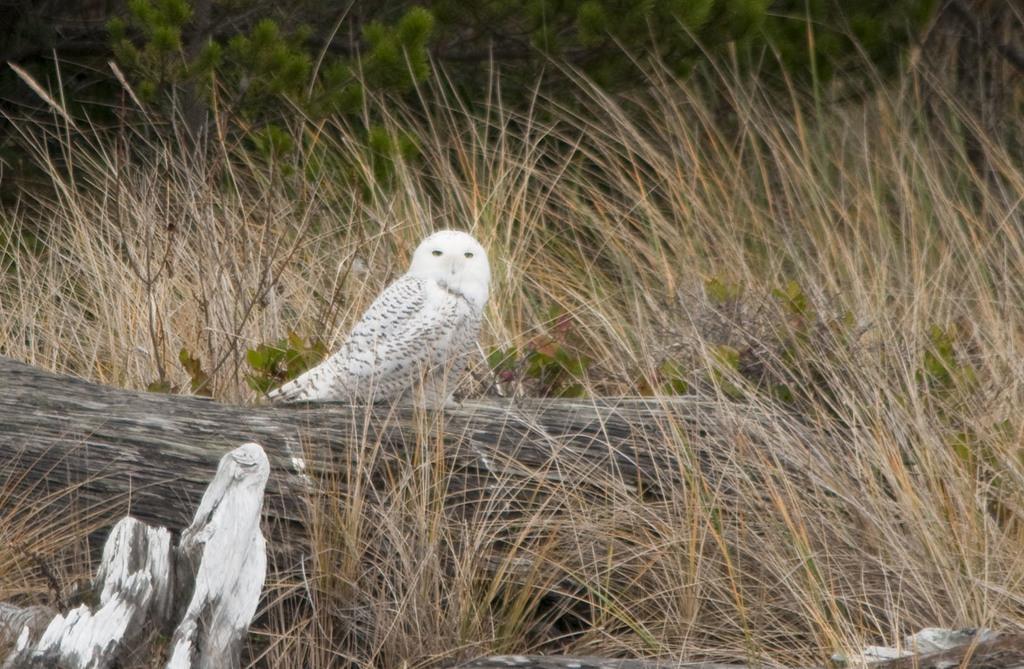Can you describe this image briefly? In this image we can see a bird on a wooden log. Around the bird we can see the grass. At the top we can see few plants. 